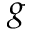<formula> <loc_0><loc_0><loc_500><loc_500>{ g }</formula> 